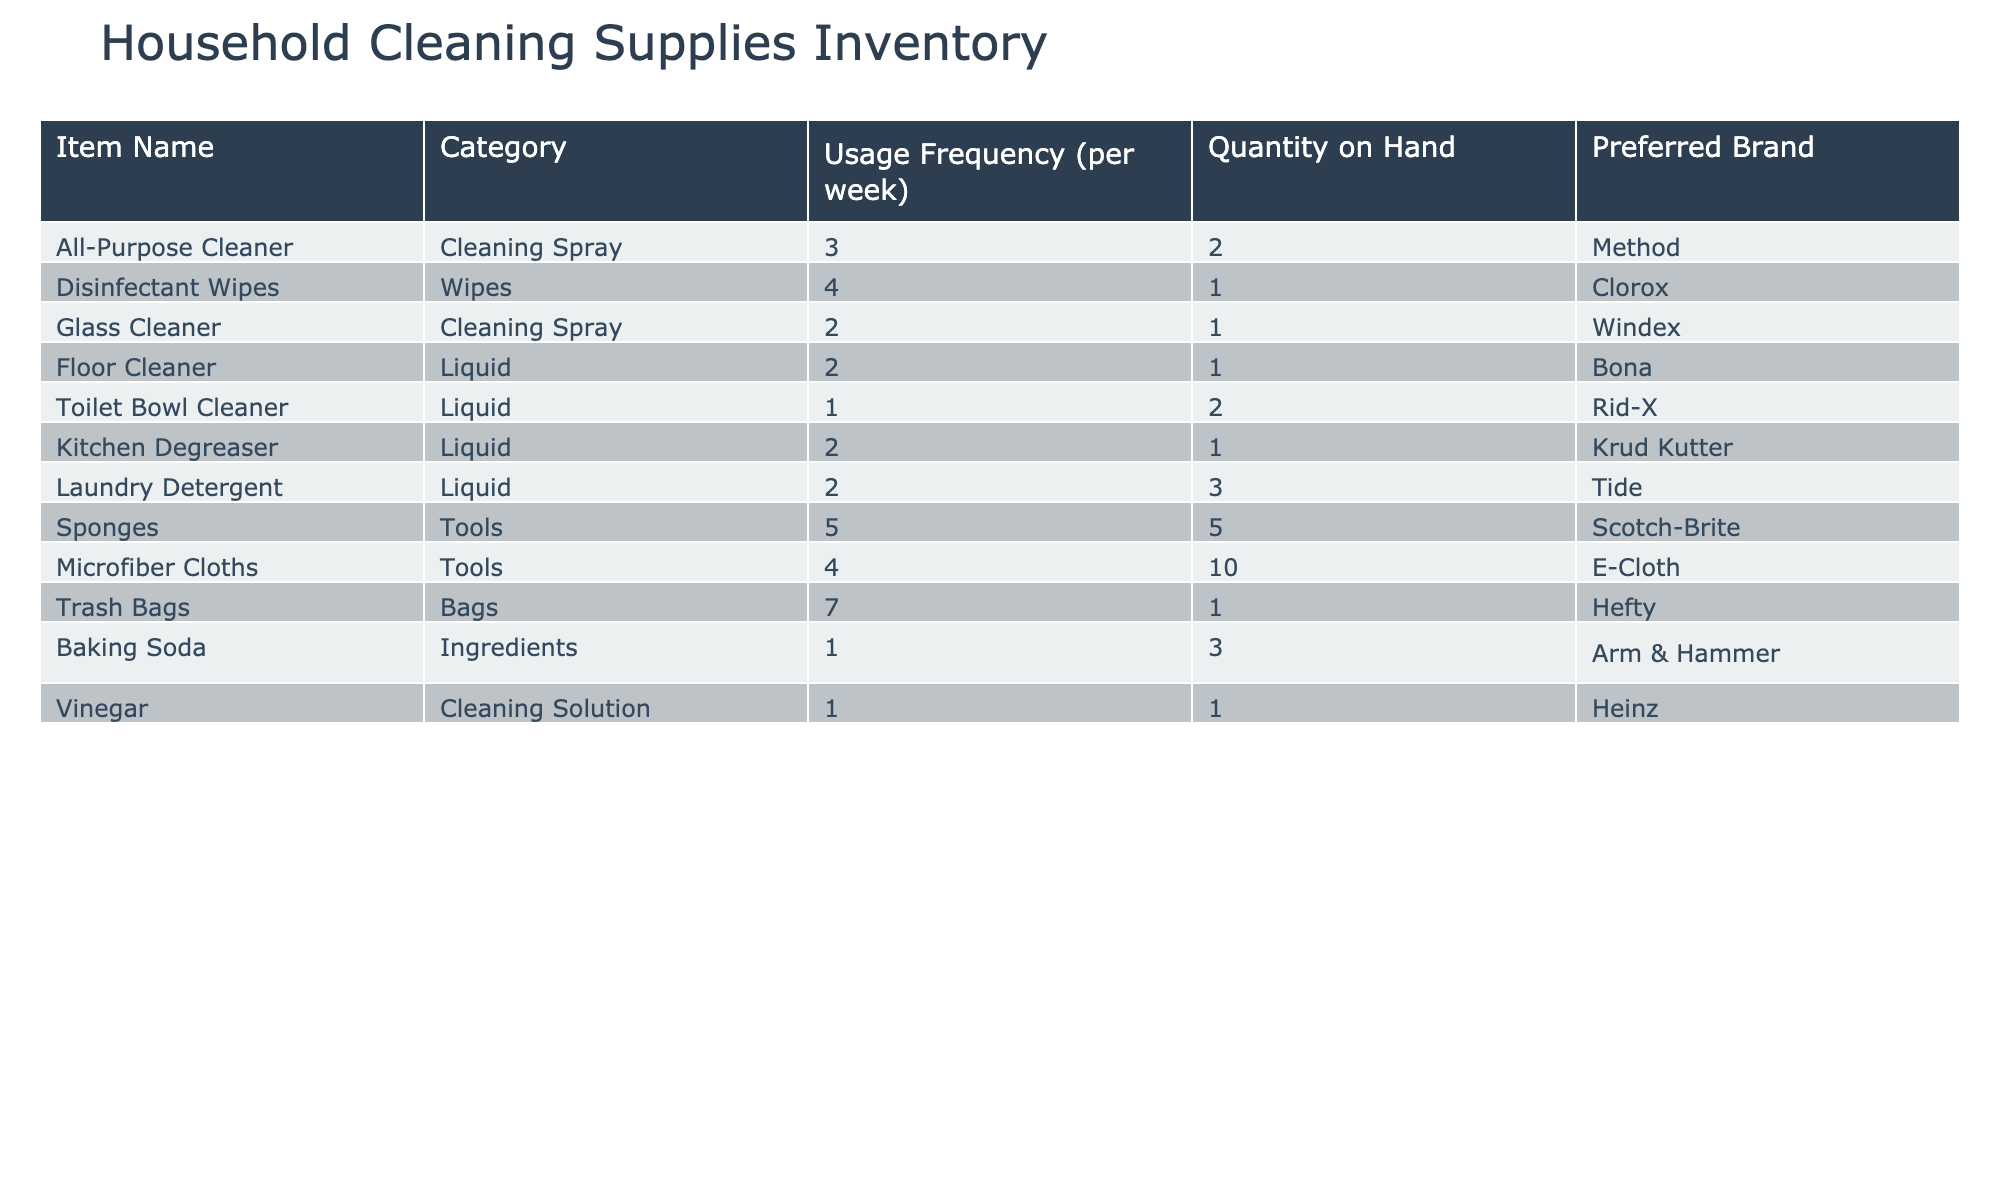What is the most frequently used cleaning supply? From the table, the item with the highest usage frequency is Trash Bags, which are used 7 times per week.
Answer: Trash Bags How many total cleaning supplies have a usage frequency of 2 or more per week? By reviewing the usage frequency column, the items with a usage frequency of at least 2 per week are: All-Purpose Cleaner, Disinfectant Wipes, Glass Cleaner, Floor Cleaner, Kitchen Degreaser, Laundry Detergent, Sponges, and Microfiber Cloths. Counting these items gives a total of 8.
Answer: 8 Does the preferred brand for Sponges match that of Microfiber Cloths? The preferred brand for Sponges is Scotch-Brite and for Microfiber Cloths, it is E-Cloth. Since these are different brands, the answer is no.
Answer: No What is the total quantity of cleaning supplies that have a higher usage frequency than 3? Only Trash Bags (7 uses) and Disinfectant Wipes (4 uses) have a frequency higher than 3. Their total quantity on hand is 1 (Trash Bags) + 1 (Disinfectant Wipes) = 2.
Answer: 2 Which cleaning supply has the lowest quantity on hand, and what is that quantity? By examining the Quantity on Hand column, the supplies with the lowest quantity are Disinfectant Wipes, Glass Cleaner, Floor Cleaner, and Vinegar with only 1 item each. Thus, the cleaning supply with the lowest quantity is Disinfectant Wipes, Glass Cleaner, Floor Cleaner, and Vinegar, and their quantity is 1.
Answer: 1 How many items have a preferred brand starting with the letter ‘K’? Reviewing the Preferred Brand column, only the Kitchen Degreaser has a brand that starts with the letter 'K' (Krud Kutter). Thus, there is 1 item.
Answer: 1 What is the average usage frequency of all the cleaning supplies listed? Adding up the usage frequencies: 3 + 4 + 2 + 2 + 1 + 2 + 2 + 5 + 4 + 7 + 1 + 1 = 34. There are 12 items total, so the average is 34 divided by 12, which is approximately 2.83.
Answer: 2.83 Is there any cleaning supply that has the same quantity on hand and usage frequency? By checking the table, the Toilet Bowl Cleaner has a quantity of 2 and a usage frequency of 1, while Sponges have a quantity of 5 and a usage frequency of 5. Hence yes, Sponges match this criteria.
Answer: Yes 